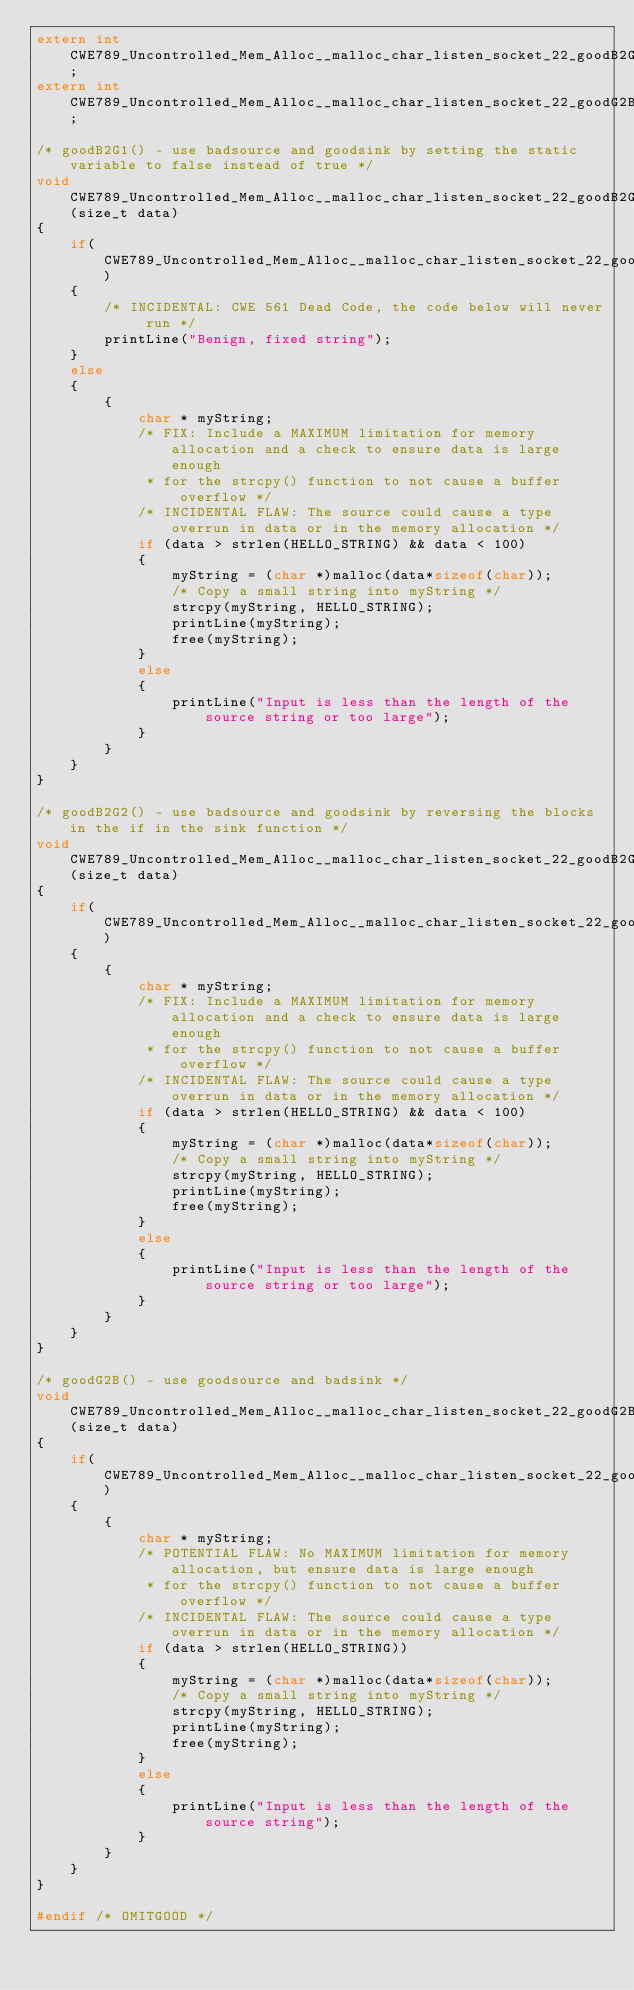Convert code to text. <code><loc_0><loc_0><loc_500><loc_500><_C_>extern int CWE789_Uncontrolled_Mem_Alloc__malloc_char_listen_socket_22_goodB2G2Global;
extern int CWE789_Uncontrolled_Mem_Alloc__malloc_char_listen_socket_22_goodG2BGlobal;

/* goodB2G1() - use badsource and goodsink by setting the static variable to false instead of true */
void CWE789_Uncontrolled_Mem_Alloc__malloc_char_listen_socket_22_goodB2G1Sink(size_t data)
{
    if(CWE789_Uncontrolled_Mem_Alloc__malloc_char_listen_socket_22_goodB2G1Global)
    {
        /* INCIDENTAL: CWE 561 Dead Code, the code below will never run */
        printLine("Benign, fixed string");
    }
    else
    {
        {
            char * myString;
            /* FIX: Include a MAXIMUM limitation for memory allocation and a check to ensure data is large enough
             * for the strcpy() function to not cause a buffer overflow */
            /* INCIDENTAL FLAW: The source could cause a type overrun in data or in the memory allocation */
            if (data > strlen(HELLO_STRING) && data < 100)
            {
                myString = (char *)malloc(data*sizeof(char));
                /* Copy a small string into myString */
                strcpy(myString, HELLO_STRING);
                printLine(myString);
                free(myString);
            }
            else
            {
                printLine("Input is less than the length of the source string or too large");
            }
        }
    }
}

/* goodB2G2() - use badsource and goodsink by reversing the blocks in the if in the sink function */
void CWE789_Uncontrolled_Mem_Alloc__malloc_char_listen_socket_22_goodB2G2Sink(size_t data)
{
    if(CWE789_Uncontrolled_Mem_Alloc__malloc_char_listen_socket_22_goodB2G2Global)
    {
        {
            char * myString;
            /* FIX: Include a MAXIMUM limitation for memory allocation and a check to ensure data is large enough
             * for the strcpy() function to not cause a buffer overflow */
            /* INCIDENTAL FLAW: The source could cause a type overrun in data or in the memory allocation */
            if (data > strlen(HELLO_STRING) && data < 100)
            {
                myString = (char *)malloc(data*sizeof(char));
                /* Copy a small string into myString */
                strcpy(myString, HELLO_STRING);
                printLine(myString);
                free(myString);
            }
            else
            {
                printLine("Input is less than the length of the source string or too large");
            }
        }
    }
}

/* goodG2B() - use goodsource and badsink */
void CWE789_Uncontrolled_Mem_Alloc__malloc_char_listen_socket_22_goodG2BSink(size_t data)
{
    if(CWE789_Uncontrolled_Mem_Alloc__malloc_char_listen_socket_22_goodG2BGlobal)
    {
        {
            char * myString;
            /* POTENTIAL FLAW: No MAXIMUM limitation for memory allocation, but ensure data is large enough
             * for the strcpy() function to not cause a buffer overflow */
            /* INCIDENTAL FLAW: The source could cause a type overrun in data or in the memory allocation */
            if (data > strlen(HELLO_STRING))
            {
                myString = (char *)malloc(data*sizeof(char));
                /* Copy a small string into myString */
                strcpy(myString, HELLO_STRING);
                printLine(myString);
                free(myString);
            }
            else
            {
                printLine("Input is less than the length of the source string");
            }
        }
    }
}

#endif /* OMITGOOD */
</code> 